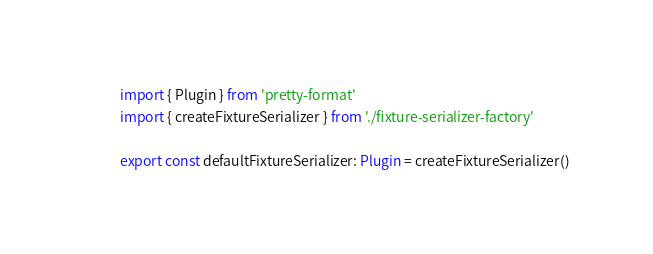Convert code to text. <code><loc_0><loc_0><loc_500><loc_500><_TypeScript_>import { Plugin } from 'pretty-format'
import { createFixtureSerializer } from './fixture-serializer-factory'

export const defaultFixtureSerializer: Plugin = createFixtureSerializer()
</code> 